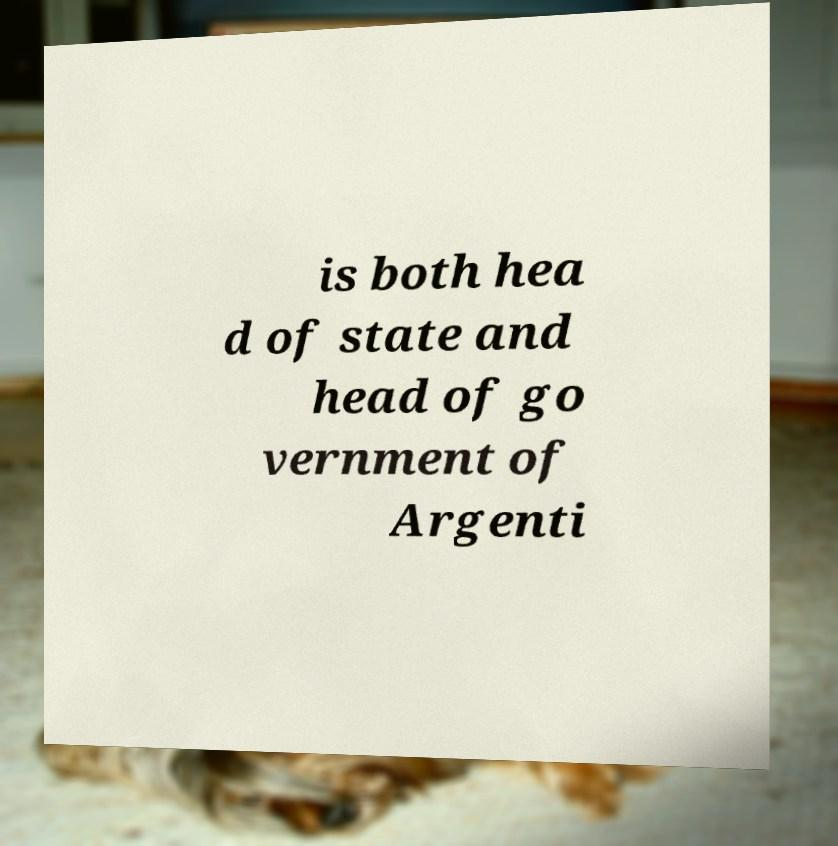I need the written content from this picture converted into text. Can you do that? is both hea d of state and head of go vernment of Argenti 